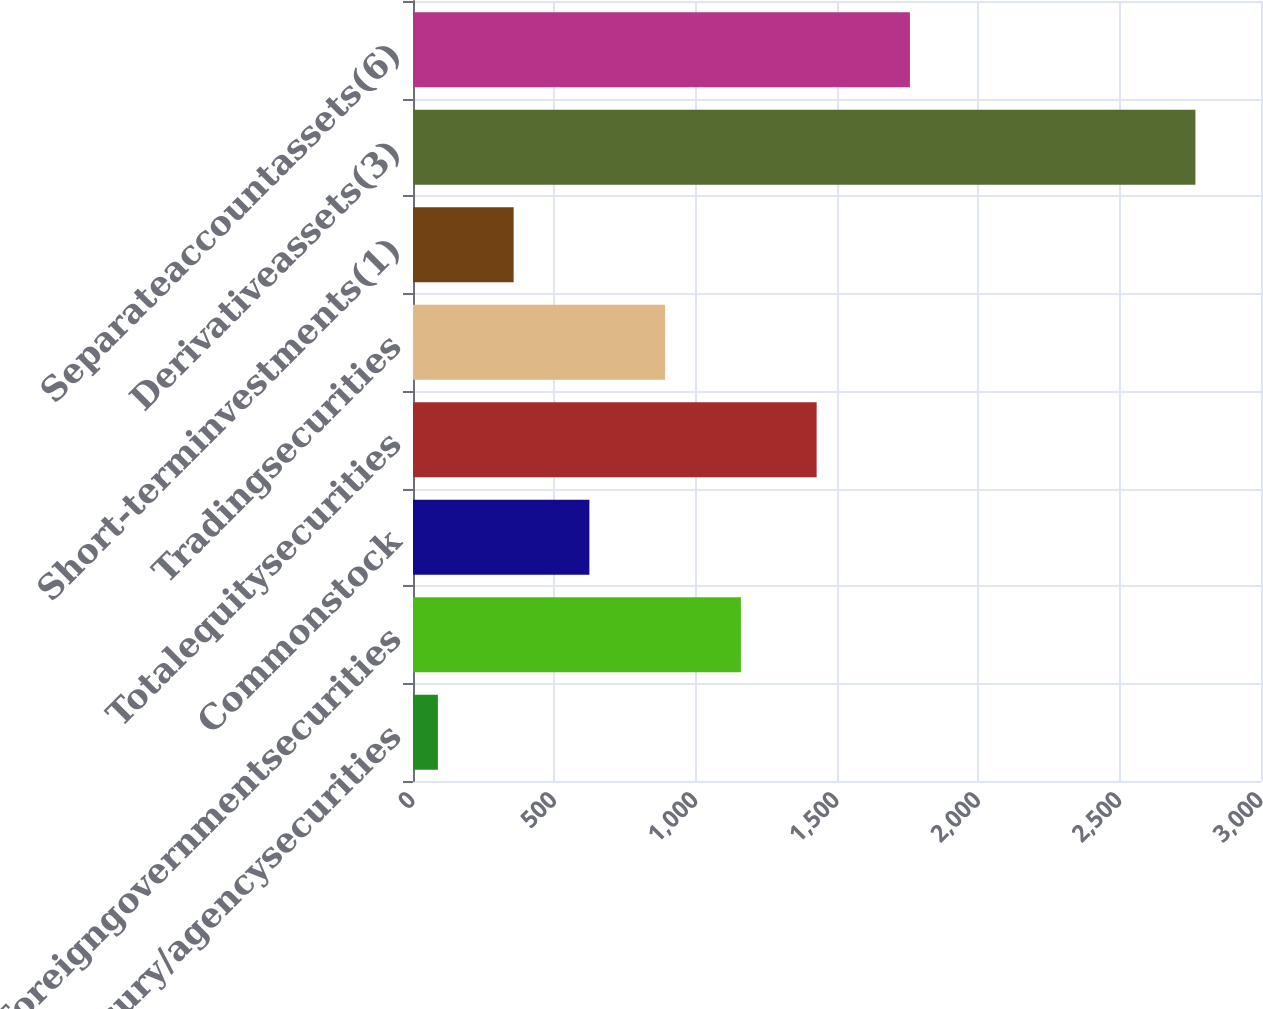<chart> <loc_0><loc_0><loc_500><loc_500><bar_chart><fcel>USTreasury/agencysecurities<fcel>Foreigngovernmentsecurities<fcel>Commonstock<fcel>Totalequitysecurities<fcel>Tradingsecurities<fcel>Short-terminvestments(1)<fcel>Derivativeassets(3)<fcel>Separateaccountassets(6)<nl><fcel>88<fcel>1160<fcel>624<fcel>1428<fcel>892<fcel>356<fcel>2768<fcel>1758<nl></chart> 